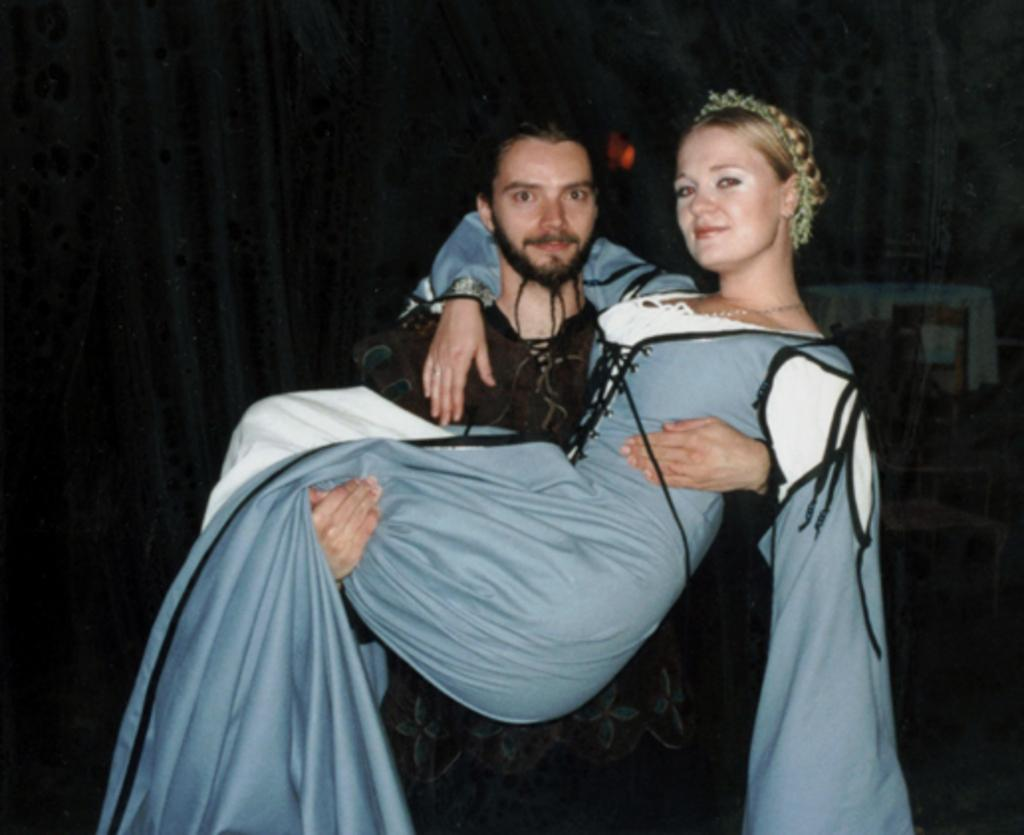What is the gender of the person in the image wearing a black dress? The person wearing a black dress in the image is a man. What is the gender of the person in the image wearing a blue dress? The person wearing a blue dress in the image is a female. What is the man doing to the female person in the image? The man is lifting the female person in the image. What can be seen in the background of the image? There is a curtain in the background of the image. What type of mitten is the man wearing in the image? There is no mitten visible in the image; the man is wearing a black dress. 